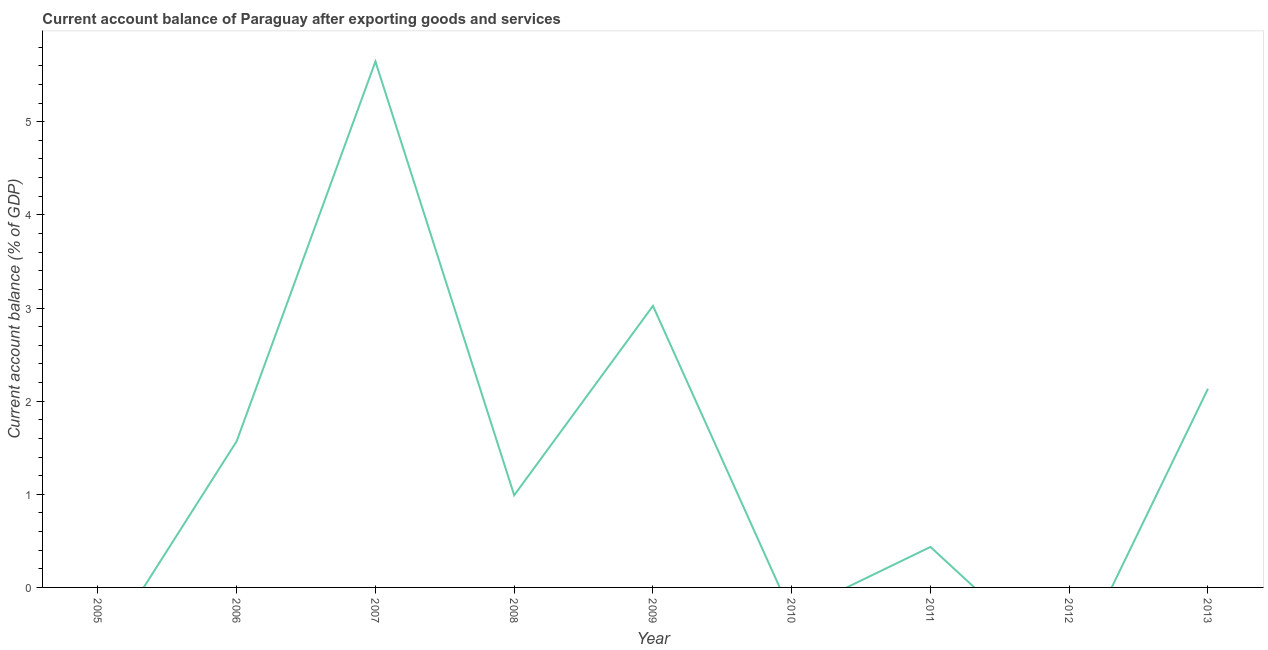What is the current account balance in 2012?
Offer a terse response. 0. Across all years, what is the maximum current account balance?
Your answer should be compact. 5.65. Across all years, what is the minimum current account balance?
Your answer should be compact. 0. What is the sum of the current account balance?
Offer a terse response. 13.8. What is the difference between the current account balance in 2011 and 2013?
Provide a succinct answer. -1.7. What is the average current account balance per year?
Give a very brief answer. 1.53. What is the median current account balance?
Provide a short and direct response. 0.99. In how many years, is the current account balance greater than 4.2 %?
Make the answer very short. 1. What is the ratio of the current account balance in 2008 to that in 2009?
Ensure brevity in your answer.  0.33. What is the difference between the highest and the second highest current account balance?
Provide a short and direct response. 2.62. Is the sum of the current account balance in 2007 and 2011 greater than the maximum current account balance across all years?
Ensure brevity in your answer.  Yes. What is the difference between the highest and the lowest current account balance?
Provide a succinct answer. 5.65. How many years are there in the graph?
Your answer should be very brief. 9. Does the graph contain any zero values?
Provide a short and direct response. Yes. Does the graph contain grids?
Offer a very short reply. No. What is the title of the graph?
Your response must be concise. Current account balance of Paraguay after exporting goods and services. What is the label or title of the Y-axis?
Your answer should be very brief. Current account balance (% of GDP). What is the Current account balance (% of GDP) in 2006?
Provide a succinct answer. 1.57. What is the Current account balance (% of GDP) of 2007?
Your response must be concise. 5.65. What is the Current account balance (% of GDP) of 2008?
Make the answer very short. 0.99. What is the Current account balance (% of GDP) in 2009?
Provide a short and direct response. 3.02. What is the Current account balance (% of GDP) of 2010?
Keep it short and to the point. 0. What is the Current account balance (% of GDP) of 2011?
Provide a short and direct response. 0.43. What is the Current account balance (% of GDP) in 2012?
Make the answer very short. 0. What is the Current account balance (% of GDP) of 2013?
Make the answer very short. 2.13. What is the difference between the Current account balance (% of GDP) in 2006 and 2007?
Keep it short and to the point. -4.08. What is the difference between the Current account balance (% of GDP) in 2006 and 2008?
Provide a succinct answer. 0.58. What is the difference between the Current account balance (% of GDP) in 2006 and 2009?
Provide a short and direct response. -1.45. What is the difference between the Current account balance (% of GDP) in 2006 and 2011?
Provide a succinct answer. 1.14. What is the difference between the Current account balance (% of GDP) in 2006 and 2013?
Provide a short and direct response. -0.56. What is the difference between the Current account balance (% of GDP) in 2007 and 2008?
Make the answer very short. 4.66. What is the difference between the Current account balance (% of GDP) in 2007 and 2009?
Offer a very short reply. 2.62. What is the difference between the Current account balance (% of GDP) in 2007 and 2011?
Keep it short and to the point. 5.21. What is the difference between the Current account balance (% of GDP) in 2007 and 2013?
Ensure brevity in your answer.  3.51. What is the difference between the Current account balance (% of GDP) in 2008 and 2009?
Your answer should be compact. -2.03. What is the difference between the Current account balance (% of GDP) in 2008 and 2011?
Your answer should be very brief. 0.56. What is the difference between the Current account balance (% of GDP) in 2008 and 2013?
Provide a succinct answer. -1.14. What is the difference between the Current account balance (% of GDP) in 2009 and 2011?
Your answer should be compact. 2.59. What is the difference between the Current account balance (% of GDP) in 2009 and 2013?
Your answer should be very brief. 0.89. What is the difference between the Current account balance (% of GDP) in 2011 and 2013?
Give a very brief answer. -1.7. What is the ratio of the Current account balance (% of GDP) in 2006 to that in 2007?
Keep it short and to the point. 0.28. What is the ratio of the Current account balance (% of GDP) in 2006 to that in 2008?
Keep it short and to the point. 1.59. What is the ratio of the Current account balance (% of GDP) in 2006 to that in 2009?
Provide a succinct answer. 0.52. What is the ratio of the Current account balance (% of GDP) in 2006 to that in 2011?
Make the answer very short. 3.61. What is the ratio of the Current account balance (% of GDP) in 2006 to that in 2013?
Ensure brevity in your answer.  0.74. What is the ratio of the Current account balance (% of GDP) in 2007 to that in 2008?
Offer a terse response. 5.71. What is the ratio of the Current account balance (% of GDP) in 2007 to that in 2009?
Provide a short and direct response. 1.87. What is the ratio of the Current account balance (% of GDP) in 2007 to that in 2011?
Offer a terse response. 12.99. What is the ratio of the Current account balance (% of GDP) in 2007 to that in 2013?
Your response must be concise. 2.65. What is the ratio of the Current account balance (% of GDP) in 2008 to that in 2009?
Offer a terse response. 0.33. What is the ratio of the Current account balance (% of GDP) in 2008 to that in 2011?
Provide a short and direct response. 2.28. What is the ratio of the Current account balance (% of GDP) in 2008 to that in 2013?
Keep it short and to the point. 0.46. What is the ratio of the Current account balance (% of GDP) in 2009 to that in 2011?
Your answer should be compact. 6.95. What is the ratio of the Current account balance (% of GDP) in 2009 to that in 2013?
Offer a terse response. 1.42. What is the ratio of the Current account balance (% of GDP) in 2011 to that in 2013?
Keep it short and to the point. 0.2. 